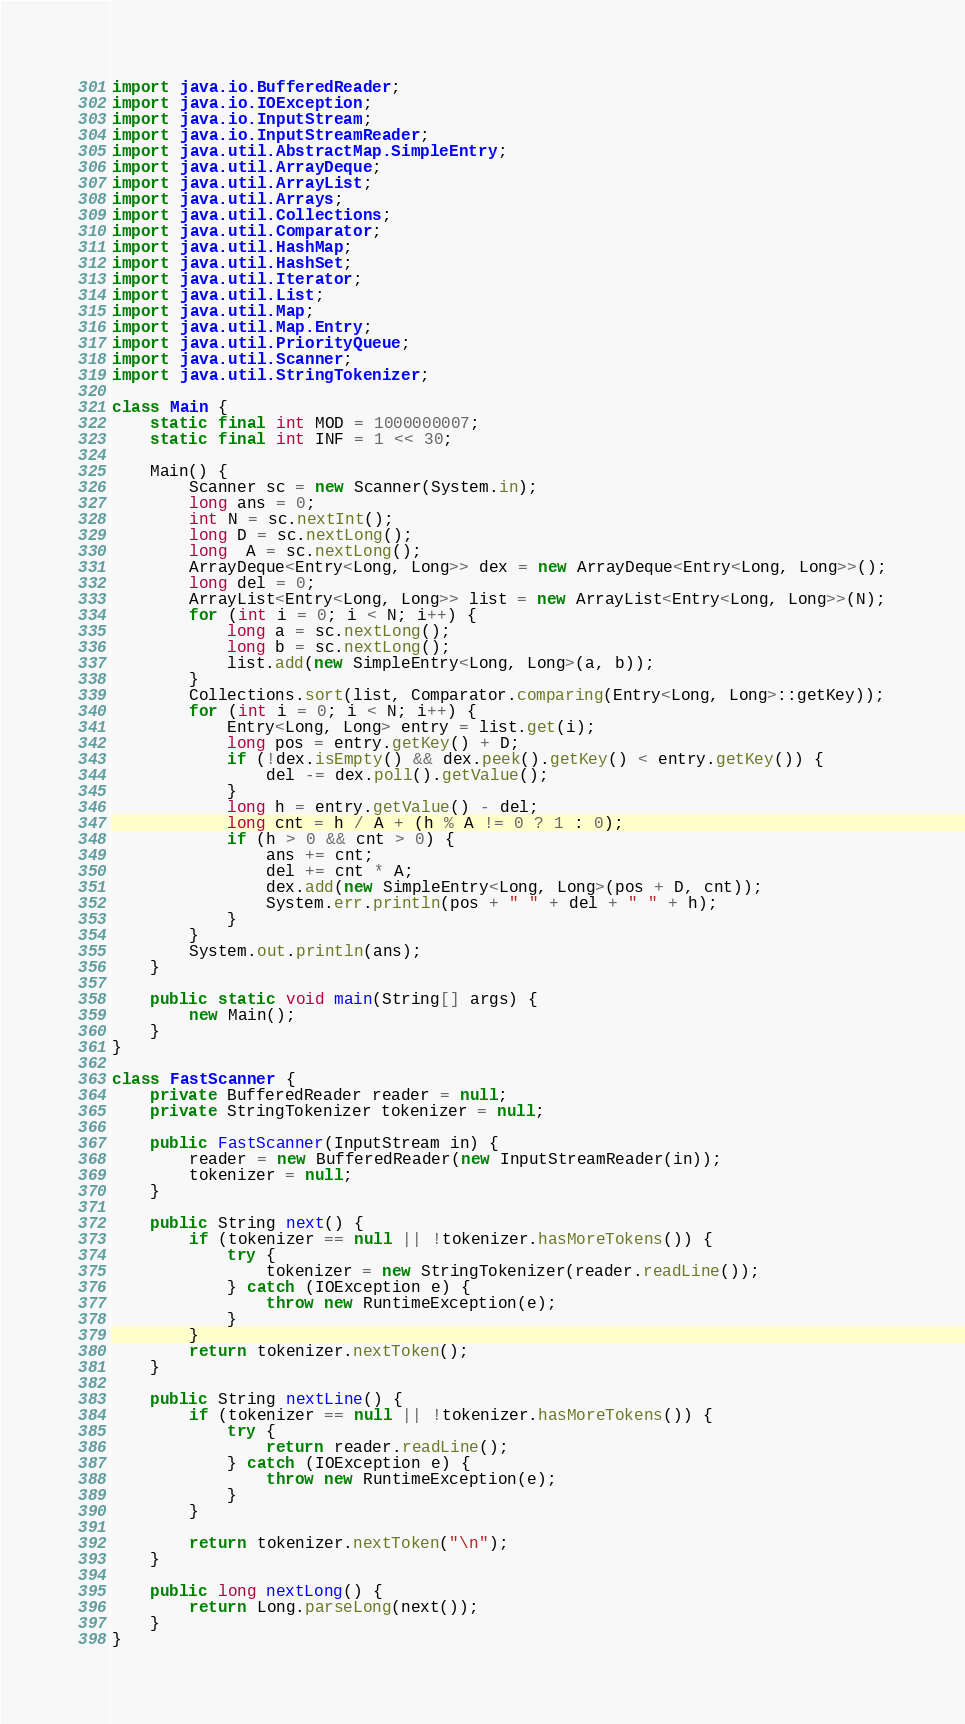Convert code to text. <code><loc_0><loc_0><loc_500><loc_500><_Java_>import java.io.BufferedReader;
import java.io.IOException;
import java.io.InputStream;
import java.io.InputStreamReader;
import java.util.AbstractMap.SimpleEntry;
import java.util.ArrayDeque;
import java.util.ArrayList;
import java.util.Arrays;
import java.util.Collections;
import java.util.Comparator;
import java.util.HashMap;
import java.util.HashSet;
import java.util.Iterator;
import java.util.List;
import java.util.Map;
import java.util.Map.Entry;
import java.util.PriorityQueue;
import java.util.Scanner;
import java.util.StringTokenizer;

class Main {
    static final int MOD = 1000000007;
    static final int INF = 1 << 30;

    Main() {
        Scanner sc = new Scanner(System.in);
        long ans = 0;
        int N = sc.nextInt();
        long D = sc.nextLong();
        long  A = sc.nextLong();
        ArrayDeque<Entry<Long, Long>> dex = new ArrayDeque<Entry<Long, Long>>();
        long del = 0;
        ArrayList<Entry<Long, Long>> list = new ArrayList<Entry<Long, Long>>(N);
        for (int i = 0; i < N; i++) {
            long a = sc.nextLong();
            long b = sc.nextLong();
            list.add(new SimpleEntry<Long, Long>(a, b));
        }
        Collections.sort(list, Comparator.comparing(Entry<Long, Long>::getKey));
        for (int i = 0; i < N; i++) {
            Entry<Long, Long> entry = list.get(i);
            long pos = entry.getKey() + D;
            if (!dex.isEmpty() && dex.peek().getKey() < entry.getKey()) {
                del -= dex.poll().getValue();
            }
            long h = entry.getValue() - del;
            long cnt = h / A + (h % A != 0 ? 1 : 0);
            if (h > 0 && cnt > 0) {
                ans += cnt;
                del += cnt * A;
                dex.add(new SimpleEntry<Long, Long>(pos + D, cnt));
                System.err.println(pos + " " + del + " " + h);
            }
        }
        System.out.println(ans);
    }

    public static void main(String[] args) {
        new Main();
    }
}

class FastScanner {
    private BufferedReader reader = null;
    private StringTokenizer tokenizer = null;

    public FastScanner(InputStream in) {
        reader = new BufferedReader(new InputStreamReader(in));
        tokenizer = null;
    }

    public String next() {
        if (tokenizer == null || !tokenizer.hasMoreTokens()) {
            try {
                tokenizer = new StringTokenizer(reader.readLine());
            } catch (IOException e) {
                throw new RuntimeException(e);
            }
        }
        return tokenizer.nextToken();
    }

    public String nextLine() {
        if (tokenizer == null || !tokenizer.hasMoreTokens()) {
            try {
                return reader.readLine();
            } catch (IOException e) {
                throw new RuntimeException(e);
            }
        }

        return tokenizer.nextToken("\n");
    }

    public long nextLong() {
        return Long.parseLong(next());
    }
}</code> 